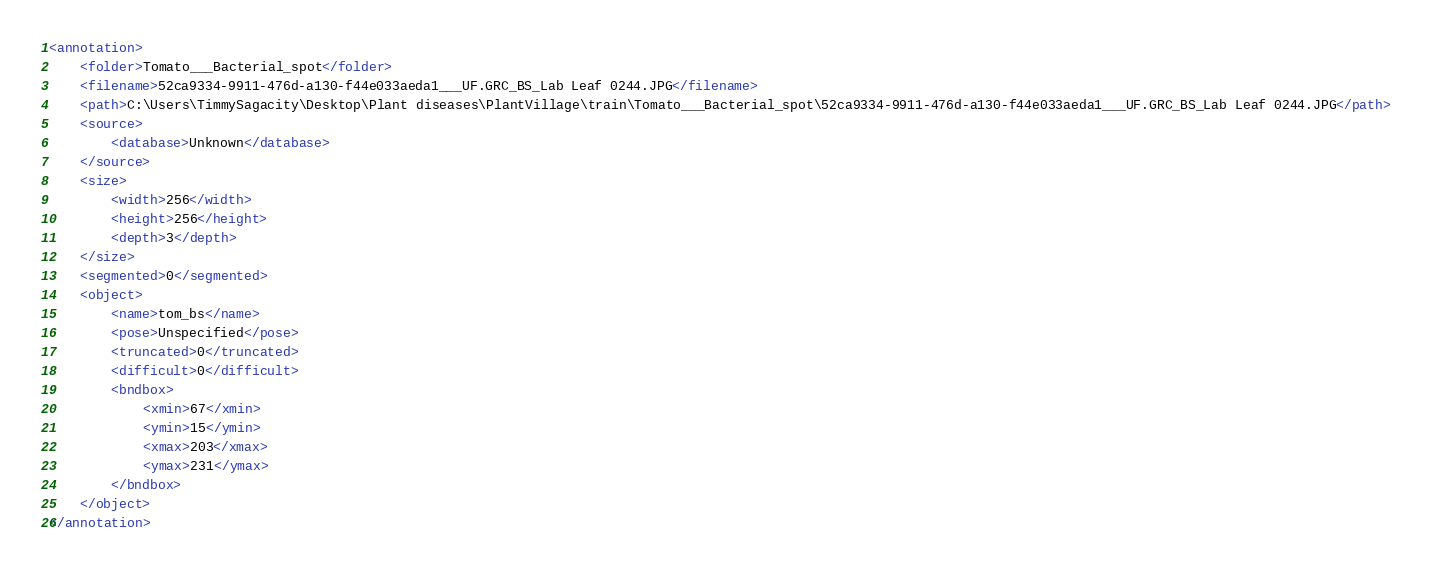<code> <loc_0><loc_0><loc_500><loc_500><_XML_><annotation>
	<folder>Tomato___Bacterial_spot</folder>
	<filename>52ca9334-9911-476d-a130-f44e033aeda1___UF.GRC_BS_Lab Leaf 0244.JPG</filename>
	<path>C:\Users\TimmySagacity\Desktop\Plant diseases\PlantVillage\train\Tomato___Bacterial_spot\52ca9334-9911-476d-a130-f44e033aeda1___UF.GRC_BS_Lab Leaf 0244.JPG</path>
	<source>
		<database>Unknown</database>
	</source>
	<size>
		<width>256</width>
		<height>256</height>
		<depth>3</depth>
	</size>
	<segmented>0</segmented>
	<object>
		<name>tom_bs</name>
		<pose>Unspecified</pose>
		<truncated>0</truncated>
		<difficult>0</difficult>
		<bndbox>
			<xmin>67</xmin>
			<ymin>15</ymin>
			<xmax>203</xmax>
			<ymax>231</ymax>
		</bndbox>
	</object>
</annotation>
</code> 